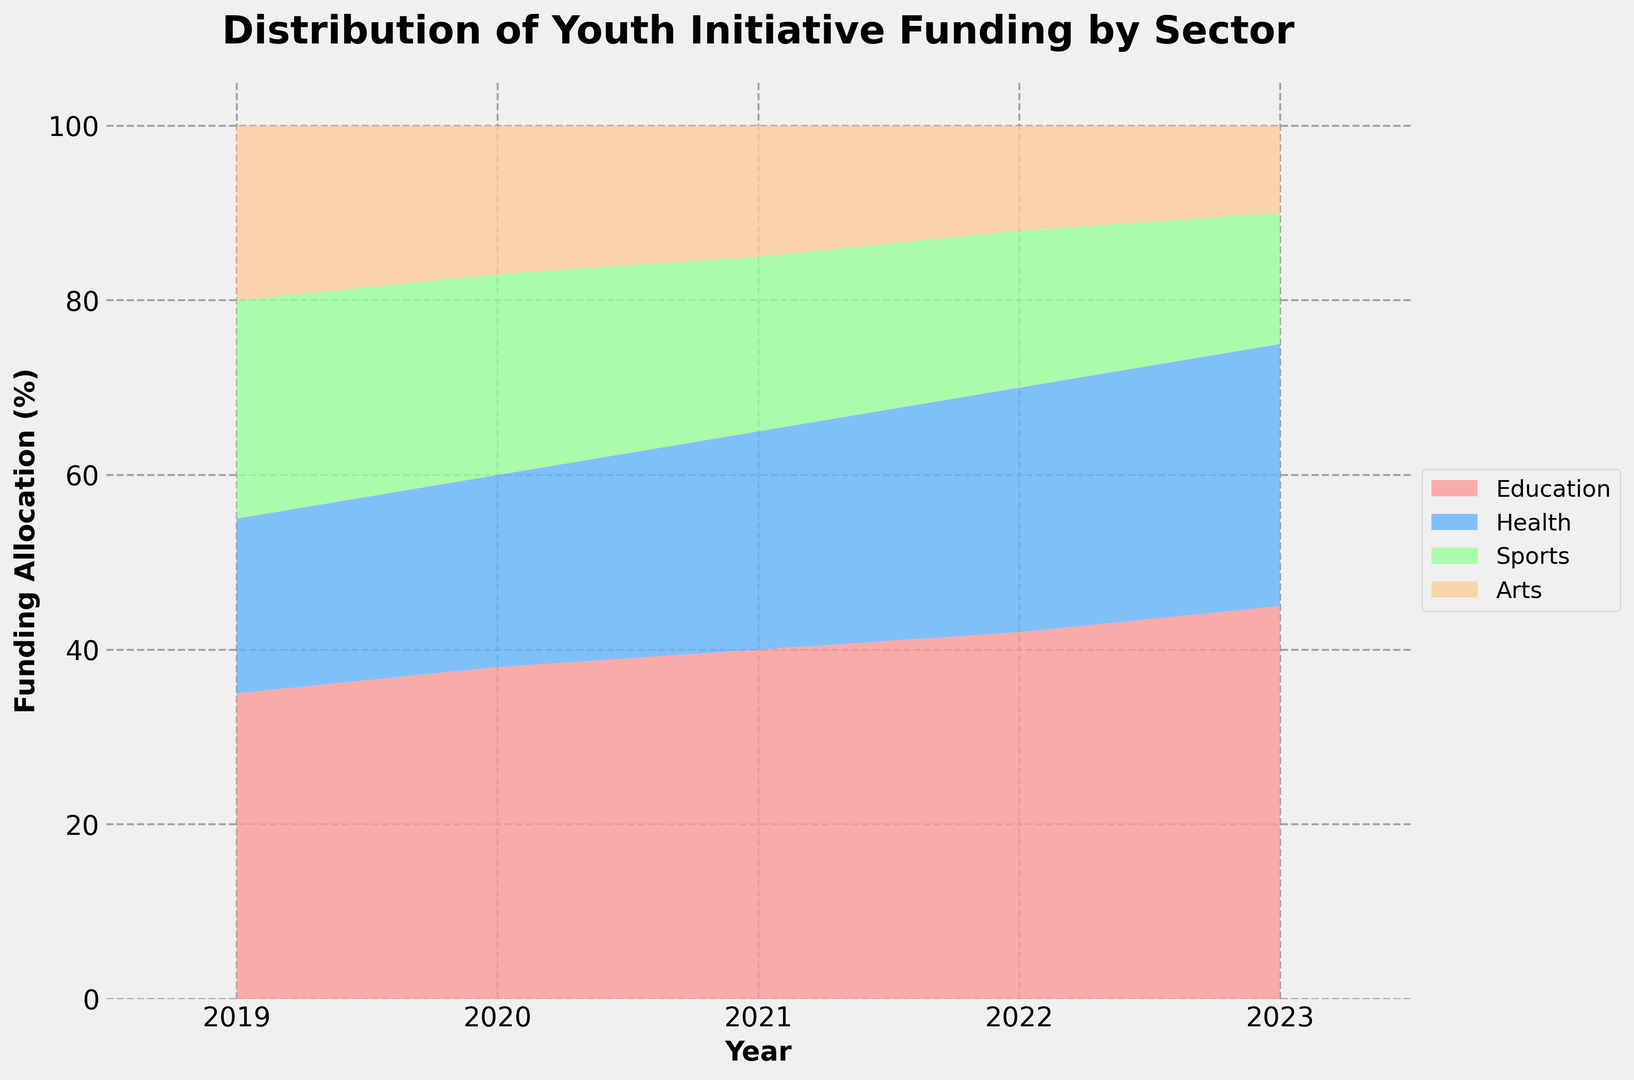What percentage of funding was allocated to Education in 2019 compared to 2023? From the figure, observe the Education sector's area for 2019 and 2023. In 2019, it was 35%, and in 2023, it was 45%. The comparison shows an increase.
Answer: 35% in 2019, 45% in 2023 In which year did Health receive the largest increase in funding allocation compared to the previous year? Look at the area chart, specifically focusing on the Health sector. The change from 2021 (25%) to 2022 (28%) is the largest increase, which is 3%.
Answer: 2022 How does the funding for Sports in 2023 compare to the funding for Arts in 2021? Check the area heights for Sports in 2023 and Arts in 2021 from the figure. Sports in 2023 has 15%, and Arts in 2021 has 15%. The allocations are equal.
Answer: Equal What is the total percentage increase in funding allocation for Education from 2019 to 2023? Identify the percentage for Education in 2019 (35%) and in 2023 (45%). Subtract the earlier value from the later value: 45% - 35% = 10%.
Answer: 10% Compare the trend of Arts funding allocation with the trend of Sports allocation over the 5 years. By examining the visual slope and area sizes for both Arts and Sports, Arts funding shows a consistent decrease, while Sports funding also decreases but at different rates.
Answer: Both decrease, Arts more consistently What was the average funding allocation for Health over the 5 years? Sum the percentages of Health for each year (20% + 22% + 25% + 28% + 30%) and divide by the number of years (5): (20 + 22 + 25 + 28 + 30) / 5 = 25%.
Answer: 25% Which sector had the least funding allocation every year? By observing the smallest areas in the chart for each year, Arts has the lowest value from 2019 through 2023.
Answer: Arts What is the difference in funding allocation between Education and Health in 2023? Identify the percentages for both Education (45%) and Health (30%) in 2023. Subtract Health's allocation from Education's: 45% - 30% = 15%.
Answer: 15% In which year did the Sports sector funding allocation decrease the most compared to the previous year? Look at the decreasing slopes for Sports. The largest drop is from 2021 (20%) to 2022 (18%), a decrease of 2%.
Answer: 2022 How much did the funding allocation for Health increase from 2019 to 2023 and what was the annual average increase? Calculate the total increase: 30% (2023) - 20% (2019) = 10%. There are 4 intervals to consider (5 years - 1), so the average annual increase is 10% / 4 = 2.5%.
Answer: Increase: 10%, Average Annual: 2.5% 